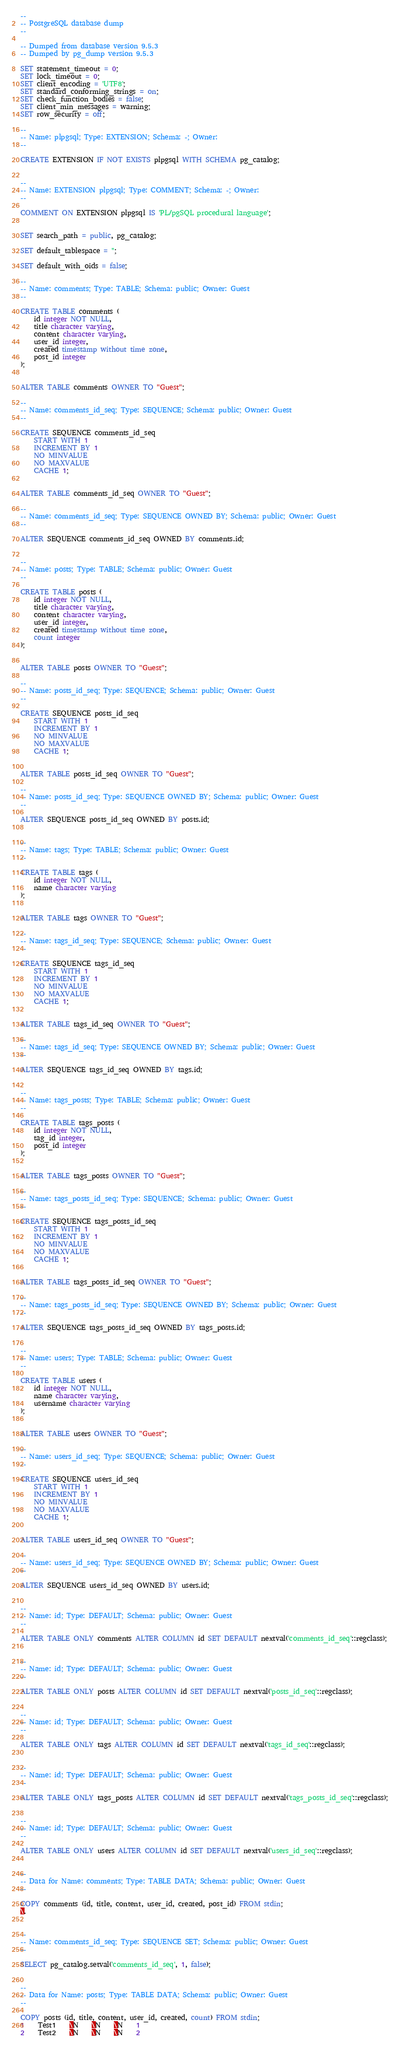Convert code to text. <code><loc_0><loc_0><loc_500><loc_500><_SQL_>--
-- PostgreSQL database dump
--

-- Dumped from database version 9.5.3
-- Dumped by pg_dump version 9.5.3

SET statement_timeout = 0;
SET lock_timeout = 0;
SET client_encoding = 'UTF8';
SET standard_conforming_strings = on;
SET check_function_bodies = false;
SET client_min_messages = warning;
SET row_security = off;

--
-- Name: plpgsql; Type: EXTENSION; Schema: -; Owner: 
--

CREATE EXTENSION IF NOT EXISTS plpgsql WITH SCHEMA pg_catalog;


--
-- Name: EXTENSION plpgsql; Type: COMMENT; Schema: -; Owner: 
--

COMMENT ON EXTENSION plpgsql IS 'PL/pgSQL procedural language';


SET search_path = public, pg_catalog;

SET default_tablespace = '';

SET default_with_oids = false;

--
-- Name: comments; Type: TABLE; Schema: public; Owner: Guest
--

CREATE TABLE comments (
    id integer NOT NULL,
    title character varying,
    content character varying,
    user_id integer,
    created timestamp without time zone,
    post_id integer
);


ALTER TABLE comments OWNER TO "Guest";

--
-- Name: comments_id_seq; Type: SEQUENCE; Schema: public; Owner: Guest
--

CREATE SEQUENCE comments_id_seq
    START WITH 1
    INCREMENT BY 1
    NO MINVALUE
    NO MAXVALUE
    CACHE 1;


ALTER TABLE comments_id_seq OWNER TO "Guest";

--
-- Name: comments_id_seq; Type: SEQUENCE OWNED BY; Schema: public; Owner: Guest
--

ALTER SEQUENCE comments_id_seq OWNED BY comments.id;


--
-- Name: posts; Type: TABLE; Schema: public; Owner: Guest
--

CREATE TABLE posts (
    id integer NOT NULL,
    title character varying,
    content character varying,
    user_id integer,
    created timestamp without time zone,
    count integer
);


ALTER TABLE posts OWNER TO "Guest";

--
-- Name: posts_id_seq; Type: SEQUENCE; Schema: public; Owner: Guest
--

CREATE SEQUENCE posts_id_seq
    START WITH 1
    INCREMENT BY 1
    NO MINVALUE
    NO MAXVALUE
    CACHE 1;


ALTER TABLE posts_id_seq OWNER TO "Guest";

--
-- Name: posts_id_seq; Type: SEQUENCE OWNED BY; Schema: public; Owner: Guest
--

ALTER SEQUENCE posts_id_seq OWNED BY posts.id;


--
-- Name: tags; Type: TABLE; Schema: public; Owner: Guest
--

CREATE TABLE tags (
    id integer NOT NULL,
    name character varying
);


ALTER TABLE tags OWNER TO "Guest";

--
-- Name: tags_id_seq; Type: SEQUENCE; Schema: public; Owner: Guest
--

CREATE SEQUENCE tags_id_seq
    START WITH 1
    INCREMENT BY 1
    NO MINVALUE
    NO MAXVALUE
    CACHE 1;


ALTER TABLE tags_id_seq OWNER TO "Guest";

--
-- Name: tags_id_seq; Type: SEQUENCE OWNED BY; Schema: public; Owner: Guest
--

ALTER SEQUENCE tags_id_seq OWNED BY tags.id;


--
-- Name: tags_posts; Type: TABLE; Schema: public; Owner: Guest
--

CREATE TABLE tags_posts (
    id integer NOT NULL,
    tag_id integer,
    post_id integer
);


ALTER TABLE tags_posts OWNER TO "Guest";

--
-- Name: tags_posts_id_seq; Type: SEQUENCE; Schema: public; Owner: Guest
--

CREATE SEQUENCE tags_posts_id_seq
    START WITH 1
    INCREMENT BY 1
    NO MINVALUE
    NO MAXVALUE
    CACHE 1;


ALTER TABLE tags_posts_id_seq OWNER TO "Guest";

--
-- Name: tags_posts_id_seq; Type: SEQUENCE OWNED BY; Schema: public; Owner: Guest
--

ALTER SEQUENCE tags_posts_id_seq OWNED BY tags_posts.id;


--
-- Name: users; Type: TABLE; Schema: public; Owner: Guest
--

CREATE TABLE users (
    id integer NOT NULL,
    name character varying,
    username character varying
);


ALTER TABLE users OWNER TO "Guest";

--
-- Name: users_id_seq; Type: SEQUENCE; Schema: public; Owner: Guest
--

CREATE SEQUENCE users_id_seq
    START WITH 1
    INCREMENT BY 1
    NO MINVALUE
    NO MAXVALUE
    CACHE 1;


ALTER TABLE users_id_seq OWNER TO "Guest";

--
-- Name: users_id_seq; Type: SEQUENCE OWNED BY; Schema: public; Owner: Guest
--

ALTER SEQUENCE users_id_seq OWNED BY users.id;


--
-- Name: id; Type: DEFAULT; Schema: public; Owner: Guest
--

ALTER TABLE ONLY comments ALTER COLUMN id SET DEFAULT nextval('comments_id_seq'::regclass);


--
-- Name: id; Type: DEFAULT; Schema: public; Owner: Guest
--

ALTER TABLE ONLY posts ALTER COLUMN id SET DEFAULT nextval('posts_id_seq'::regclass);


--
-- Name: id; Type: DEFAULT; Schema: public; Owner: Guest
--

ALTER TABLE ONLY tags ALTER COLUMN id SET DEFAULT nextval('tags_id_seq'::regclass);


--
-- Name: id; Type: DEFAULT; Schema: public; Owner: Guest
--

ALTER TABLE ONLY tags_posts ALTER COLUMN id SET DEFAULT nextval('tags_posts_id_seq'::regclass);


--
-- Name: id; Type: DEFAULT; Schema: public; Owner: Guest
--

ALTER TABLE ONLY users ALTER COLUMN id SET DEFAULT nextval('users_id_seq'::regclass);


--
-- Data for Name: comments; Type: TABLE DATA; Schema: public; Owner: Guest
--

COPY comments (id, title, content, user_id, created, post_id) FROM stdin;
\.


--
-- Name: comments_id_seq; Type: SEQUENCE SET; Schema: public; Owner: Guest
--

SELECT pg_catalog.setval('comments_id_seq', 1, false);


--
-- Data for Name: posts; Type: TABLE DATA; Schema: public; Owner: Guest
--

COPY posts (id, title, content, user_id, created, count) FROM stdin;
1	Test1	\N	\N	\N	1
2	Test2	\N	\N	\N	2</code> 